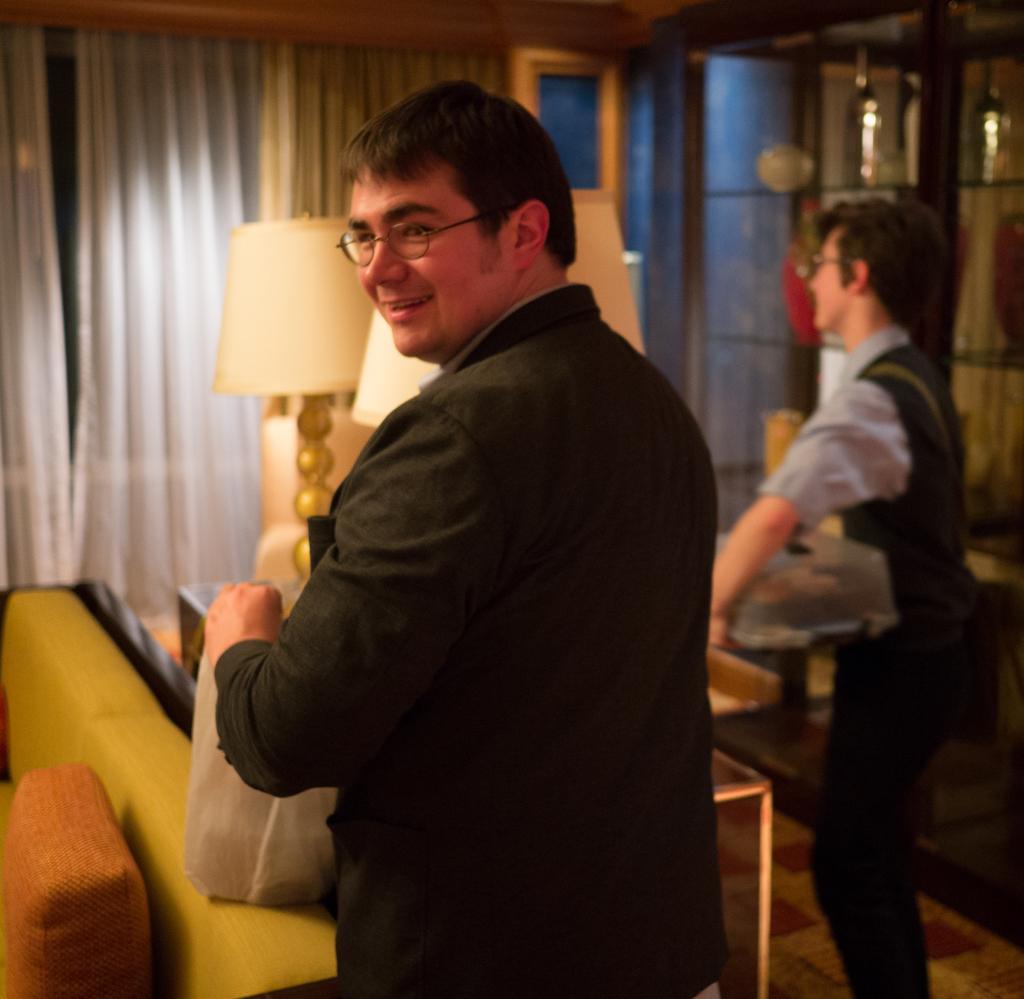Can you describe this image briefly? Here in this picture we can see two men standing on the floor and both of them are carrying bags in their hands and they are wearing spectacles and the person in the front is wearing coat and smiling and in front of him we can see a sofa with cushion present over the place and we can also see a table with a lamp present and we can see window with curtains present. 